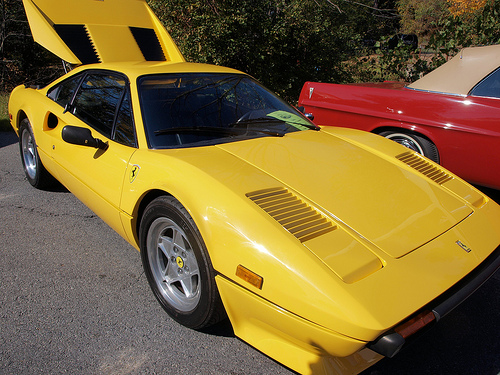<image>
Is there a red car to the right of the yellow car? Yes. From this viewpoint, the red car is positioned to the right side relative to the yellow car. 